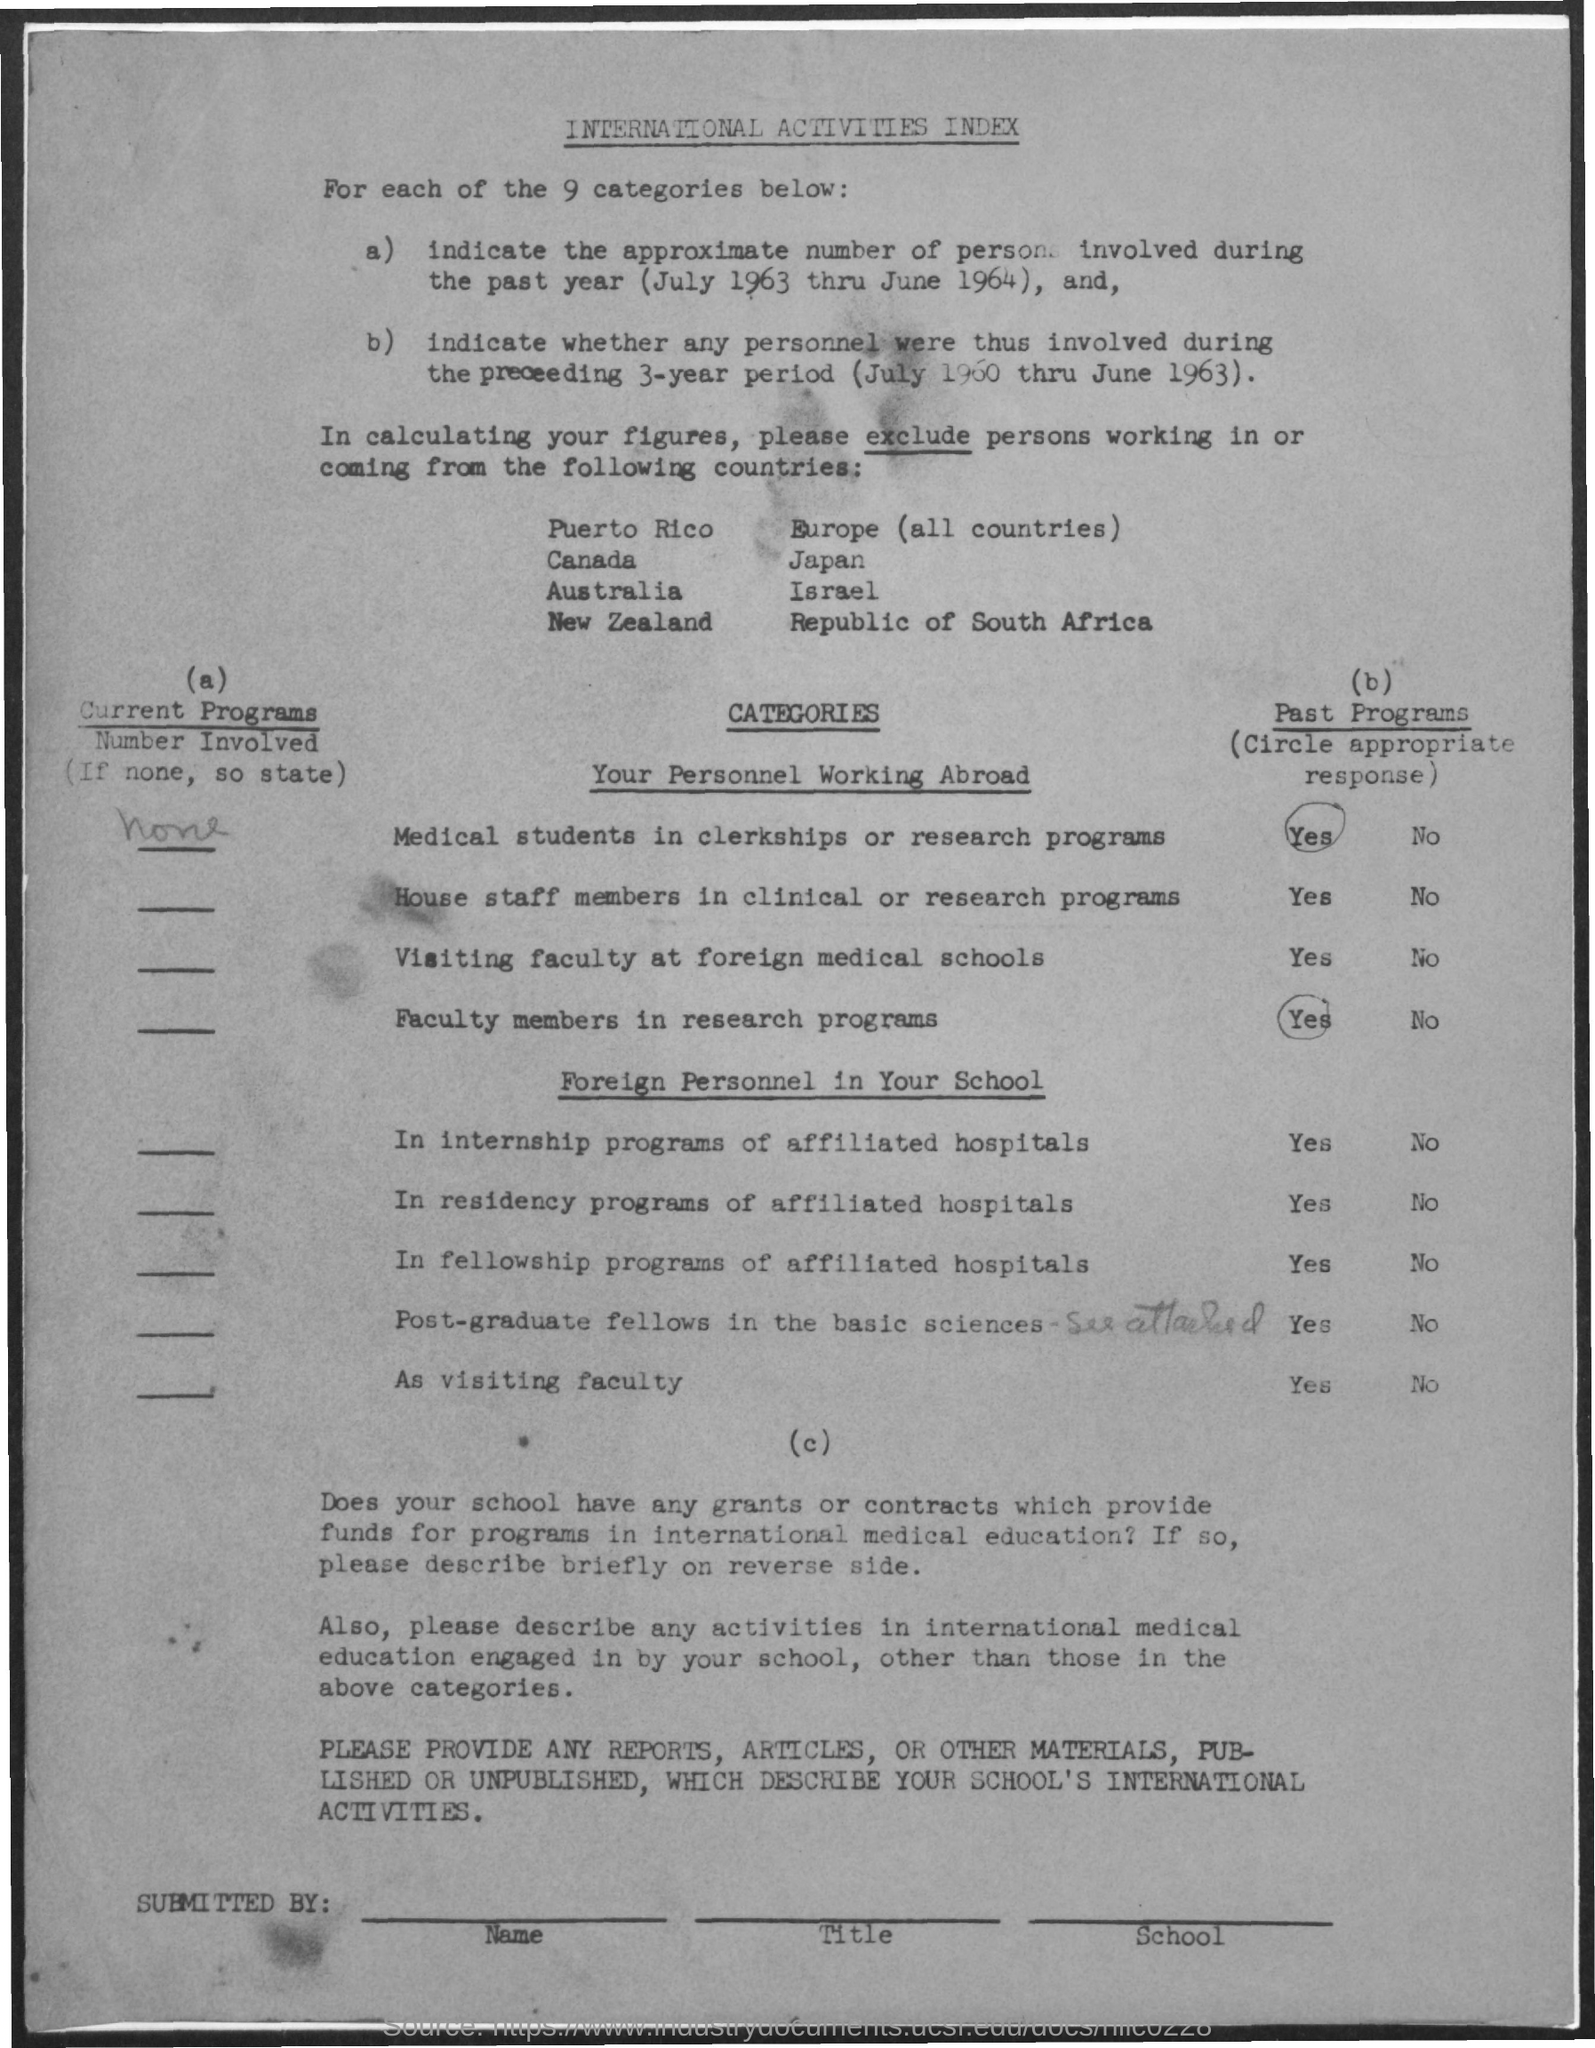Indicate a few pertinent items in this graphic. Nine categories exist. The title of the document is International Activities Index. 